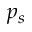<formula> <loc_0><loc_0><loc_500><loc_500>p _ { s }</formula> 